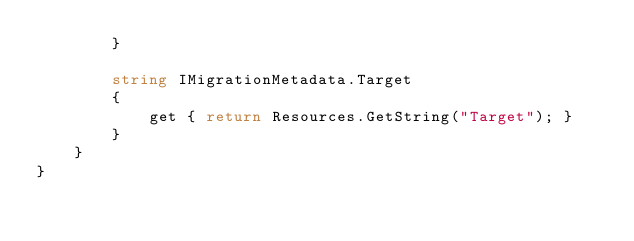Convert code to text. <code><loc_0><loc_0><loc_500><loc_500><_C#_>        }
        
        string IMigrationMetadata.Target
        {
            get { return Resources.GetString("Target"); }
        }
    }
}
</code> 